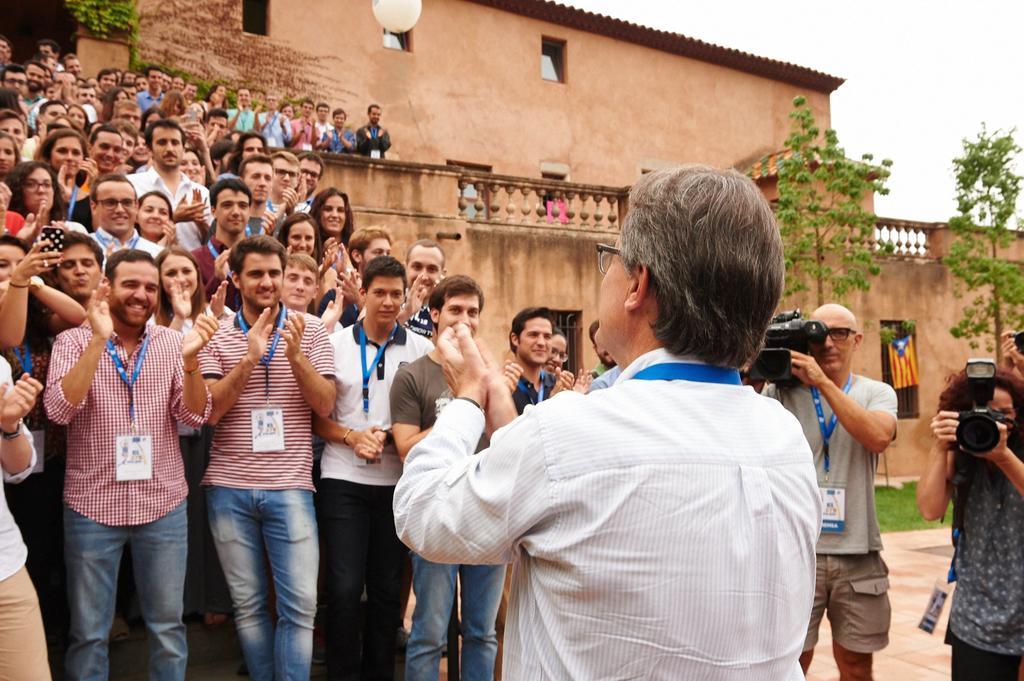How would you summarize this image in a sentence or two? This image is clicked outside. There are trees on the right side. There is sky at the top. There is a building in the middle. There are so many people standing on the left side. They are clapping. On the right side there are two persons holding cameras. 